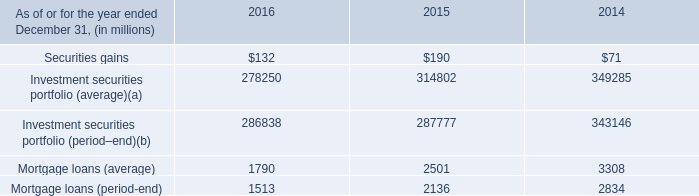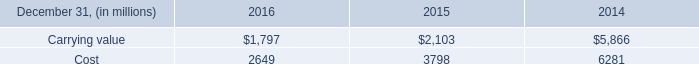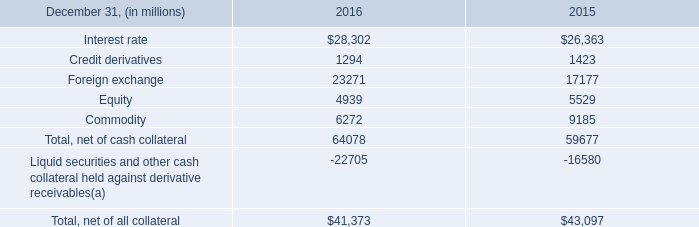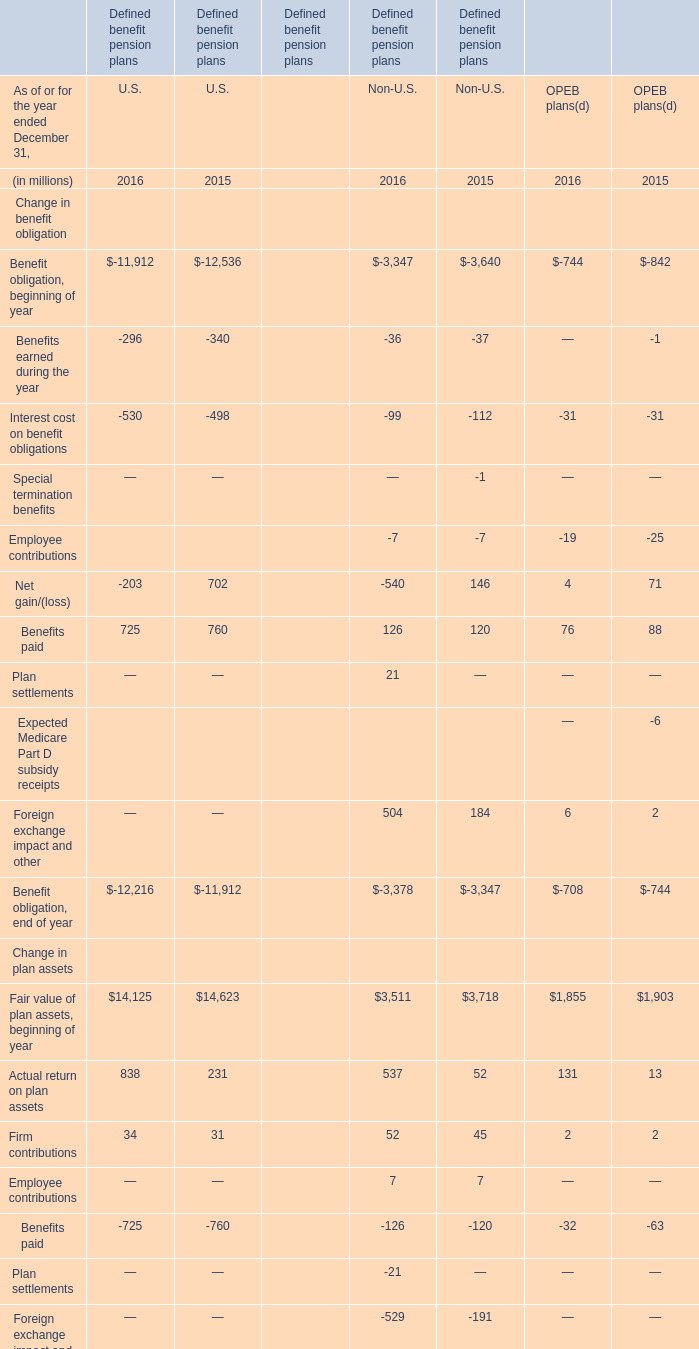What's the sum of Carrying value of 2015, Interest rate of 2016, and Accumulated benefit obligation, end of year Change in plan assets of Defined benefit pension plans U.S. 2016 ? 
Computations: ((2103.0 + 28302.0) + 12062.0)
Answer: 42467.0. 